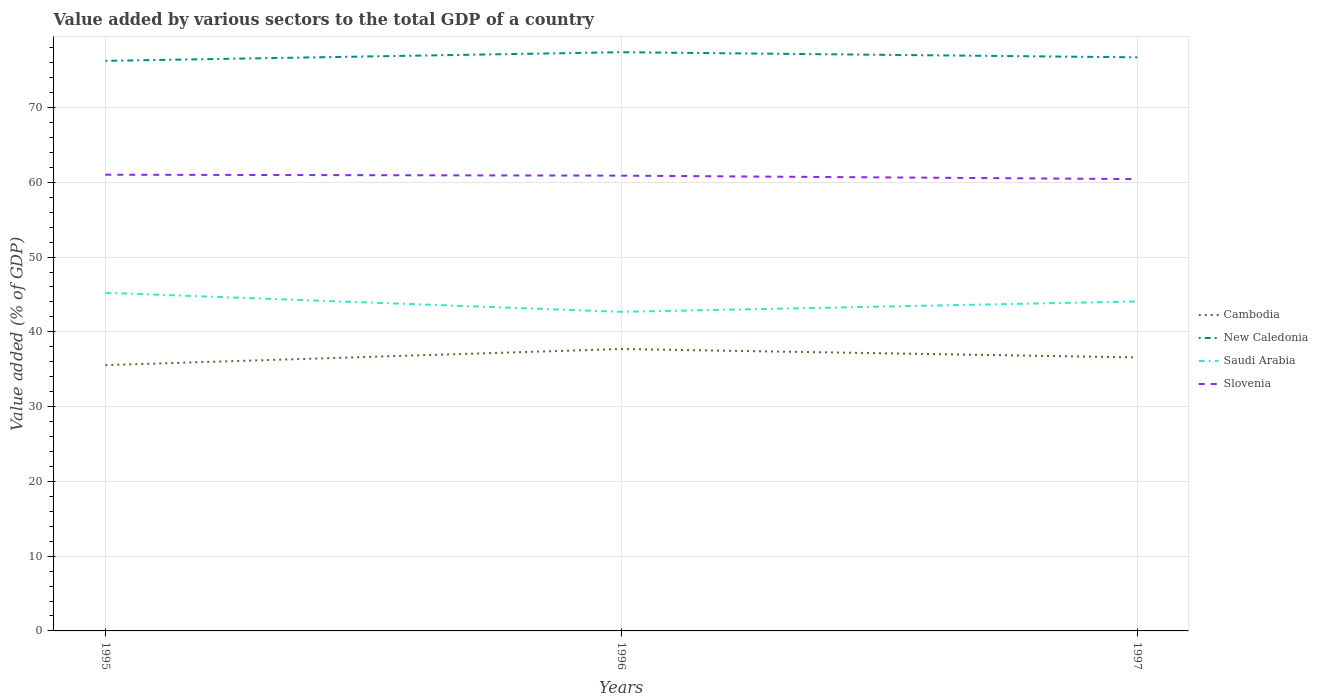How many different coloured lines are there?
Make the answer very short. 4. Does the line corresponding to Saudi Arabia intersect with the line corresponding to Cambodia?
Your answer should be very brief. No. Across all years, what is the maximum value added by various sectors to the total GDP in Slovenia?
Provide a succinct answer. 60.43. In which year was the value added by various sectors to the total GDP in Cambodia maximum?
Keep it short and to the point. 1995. What is the total value added by various sectors to the total GDP in Saudi Arabia in the graph?
Keep it short and to the point. 2.55. What is the difference between the highest and the second highest value added by various sectors to the total GDP in New Caledonia?
Your answer should be very brief. 1.15. Is the value added by various sectors to the total GDP in Saudi Arabia strictly greater than the value added by various sectors to the total GDP in Cambodia over the years?
Offer a very short reply. No. How many years are there in the graph?
Provide a succinct answer. 3. Are the values on the major ticks of Y-axis written in scientific E-notation?
Provide a short and direct response. No. Does the graph contain any zero values?
Ensure brevity in your answer.  No. How many legend labels are there?
Ensure brevity in your answer.  4. How are the legend labels stacked?
Make the answer very short. Vertical. What is the title of the graph?
Keep it short and to the point. Value added by various sectors to the total GDP of a country. What is the label or title of the X-axis?
Your response must be concise. Years. What is the label or title of the Y-axis?
Keep it short and to the point. Value added (% of GDP). What is the Value added (% of GDP) of Cambodia in 1995?
Offer a very short reply. 35.55. What is the Value added (% of GDP) in New Caledonia in 1995?
Your answer should be very brief. 76.24. What is the Value added (% of GDP) in Saudi Arabia in 1995?
Make the answer very short. 45.23. What is the Value added (% of GDP) in Slovenia in 1995?
Your answer should be compact. 61.01. What is the Value added (% of GDP) of Cambodia in 1996?
Give a very brief answer. 37.7. What is the Value added (% of GDP) in New Caledonia in 1996?
Offer a terse response. 77.4. What is the Value added (% of GDP) of Saudi Arabia in 1996?
Keep it short and to the point. 42.67. What is the Value added (% of GDP) in Slovenia in 1996?
Your answer should be compact. 60.89. What is the Value added (% of GDP) of Cambodia in 1997?
Provide a succinct answer. 36.58. What is the Value added (% of GDP) in New Caledonia in 1997?
Your answer should be very brief. 76.71. What is the Value added (% of GDP) of Saudi Arabia in 1997?
Provide a succinct answer. 44.06. What is the Value added (% of GDP) in Slovenia in 1997?
Keep it short and to the point. 60.43. Across all years, what is the maximum Value added (% of GDP) in Cambodia?
Provide a short and direct response. 37.7. Across all years, what is the maximum Value added (% of GDP) in New Caledonia?
Provide a succinct answer. 77.4. Across all years, what is the maximum Value added (% of GDP) of Saudi Arabia?
Ensure brevity in your answer.  45.23. Across all years, what is the maximum Value added (% of GDP) of Slovenia?
Ensure brevity in your answer.  61.01. Across all years, what is the minimum Value added (% of GDP) of Cambodia?
Give a very brief answer. 35.55. Across all years, what is the minimum Value added (% of GDP) in New Caledonia?
Provide a succinct answer. 76.24. Across all years, what is the minimum Value added (% of GDP) of Saudi Arabia?
Your answer should be very brief. 42.67. Across all years, what is the minimum Value added (% of GDP) in Slovenia?
Offer a terse response. 60.43. What is the total Value added (% of GDP) of Cambodia in the graph?
Offer a very short reply. 109.83. What is the total Value added (% of GDP) of New Caledonia in the graph?
Your answer should be compact. 230.36. What is the total Value added (% of GDP) of Saudi Arabia in the graph?
Offer a very short reply. 131.96. What is the total Value added (% of GDP) of Slovenia in the graph?
Your answer should be very brief. 182.33. What is the difference between the Value added (% of GDP) of Cambodia in 1995 and that in 1996?
Make the answer very short. -2.15. What is the difference between the Value added (% of GDP) in New Caledonia in 1995 and that in 1996?
Your answer should be compact. -1.15. What is the difference between the Value added (% of GDP) of Saudi Arabia in 1995 and that in 1996?
Offer a terse response. 2.55. What is the difference between the Value added (% of GDP) in Slovenia in 1995 and that in 1996?
Offer a terse response. 0.12. What is the difference between the Value added (% of GDP) of Cambodia in 1995 and that in 1997?
Offer a terse response. -1.03. What is the difference between the Value added (% of GDP) in New Caledonia in 1995 and that in 1997?
Provide a succinct answer. -0.47. What is the difference between the Value added (% of GDP) in Saudi Arabia in 1995 and that in 1997?
Ensure brevity in your answer.  1.16. What is the difference between the Value added (% of GDP) of Slovenia in 1995 and that in 1997?
Your answer should be compact. 0.59. What is the difference between the Value added (% of GDP) in Cambodia in 1996 and that in 1997?
Ensure brevity in your answer.  1.12. What is the difference between the Value added (% of GDP) of New Caledonia in 1996 and that in 1997?
Offer a very short reply. 0.68. What is the difference between the Value added (% of GDP) of Saudi Arabia in 1996 and that in 1997?
Offer a very short reply. -1.39. What is the difference between the Value added (% of GDP) of Slovenia in 1996 and that in 1997?
Offer a terse response. 0.46. What is the difference between the Value added (% of GDP) of Cambodia in 1995 and the Value added (% of GDP) of New Caledonia in 1996?
Provide a short and direct response. -41.85. What is the difference between the Value added (% of GDP) in Cambodia in 1995 and the Value added (% of GDP) in Saudi Arabia in 1996?
Keep it short and to the point. -7.12. What is the difference between the Value added (% of GDP) in Cambodia in 1995 and the Value added (% of GDP) in Slovenia in 1996?
Give a very brief answer. -25.34. What is the difference between the Value added (% of GDP) of New Caledonia in 1995 and the Value added (% of GDP) of Saudi Arabia in 1996?
Offer a very short reply. 33.57. What is the difference between the Value added (% of GDP) of New Caledonia in 1995 and the Value added (% of GDP) of Slovenia in 1996?
Give a very brief answer. 15.35. What is the difference between the Value added (% of GDP) of Saudi Arabia in 1995 and the Value added (% of GDP) of Slovenia in 1996?
Your response must be concise. -15.66. What is the difference between the Value added (% of GDP) in Cambodia in 1995 and the Value added (% of GDP) in New Caledonia in 1997?
Make the answer very short. -41.16. What is the difference between the Value added (% of GDP) of Cambodia in 1995 and the Value added (% of GDP) of Saudi Arabia in 1997?
Provide a succinct answer. -8.51. What is the difference between the Value added (% of GDP) of Cambodia in 1995 and the Value added (% of GDP) of Slovenia in 1997?
Give a very brief answer. -24.88. What is the difference between the Value added (% of GDP) in New Caledonia in 1995 and the Value added (% of GDP) in Saudi Arabia in 1997?
Your response must be concise. 32.18. What is the difference between the Value added (% of GDP) of New Caledonia in 1995 and the Value added (% of GDP) of Slovenia in 1997?
Give a very brief answer. 15.81. What is the difference between the Value added (% of GDP) of Saudi Arabia in 1995 and the Value added (% of GDP) of Slovenia in 1997?
Offer a terse response. -15.2. What is the difference between the Value added (% of GDP) in Cambodia in 1996 and the Value added (% of GDP) in New Caledonia in 1997?
Ensure brevity in your answer.  -39.01. What is the difference between the Value added (% of GDP) of Cambodia in 1996 and the Value added (% of GDP) of Saudi Arabia in 1997?
Make the answer very short. -6.36. What is the difference between the Value added (% of GDP) of Cambodia in 1996 and the Value added (% of GDP) of Slovenia in 1997?
Offer a very short reply. -22.73. What is the difference between the Value added (% of GDP) of New Caledonia in 1996 and the Value added (% of GDP) of Saudi Arabia in 1997?
Offer a very short reply. 33.33. What is the difference between the Value added (% of GDP) of New Caledonia in 1996 and the Value added (% of GDP) of Slovenia in 1997?
Your answer should be compact. 16.97. What is the difference between the Value added (% of GDP) in Saudi Arabia in 1996 and the Value added (% of GDP) in Slovenia in 1997?
Offer a terse response. -17.76. What is the average Value added (% of GDP) of Cambodia per year?
Provide a succinct answer. 36.61. What is the average Value added (% of GDP) of New Caledonia per year?
Give a very brief answer. 76.78. What is the average Value added (% of GDP) of Saudi Arabia per year?
Provide a short and direct response. 43.99. What is the average Value added (% of GDP) of Slovenia per year?
Keep it short and to the point. 60.78. In the year 1995, what is the difference between the Value added (% of GDP) in Cambodia and Value added (% of GDP) in New Caledonia?
Provide a short and direct response. -40.69. In the year 1995, what is the difference between the Value added (% of GDP) of Cambodia and Value added (% of GDP) of Saudi Arabia?
Make the answer very short. -9.68. In the year 1995, what is the difference between the Value added (% of GDP) in Cambodia and Value added (% of GDP) in Slovenia?
Offer a terse response. -25.46. In the year 1995, what is the difference between the Value added (% of GDP) in New Caledonia and Value added (% of GDP) in Saudi Arabia?
Ensure brevity in your answer.  31.02. In the year 1995, what is the difference between the Value added (% of GDP) in New Caledonia and Value added (% of GDP) in Slovenia?
Give a very brief answer. 15.23. In the year 1995, what is the difference between the Value added (% of GDP) in Saudi Arabia and Value added (% of GDP) in Slovenia?
Provide a succinct answer. -15.79. In the year 1996, what is the difference between the Value added (% of GDP) of Cambodia and Value added (% of GDP) of New Caledonia?
Offer a terse response. -39.69. In the year 1996, what is the difference between the Value added (% of GDP) in Cambodia and Value added (% of GDP) in Saudi Arabia?
Provide a short and direct response. -4.97. In the year 1996, what is the difference between the Value added (% of GDP) of Cambodia and Value added (% of GDP) of Slovenia?
Give a very brief answer. -23.19. In the year 1996, what is the difference between the Value added (% of GDP) in New Caledonia and Value added (% of GDP) in Saudi Arabia?
Give a very brief answer. 34.72. In the year 1996, what is the difference between the Value added (% of GDP) of New Caledonia and Value added (% of GDP) of Slovenia?
Provide a short and direct response. 16.51. In the year 1996, what is the difference between the Value added (% of GDP) of Saudi Arabia and Value added (% of GDP) of Slovenia?
Ensure brevity in your answer.  -18.22. In the year 1997, what is the difference between the Value added (% of GDP) of Cambodia and Value added (% of GDP) of New Caledonia?
Offer a terse response. -40.13. In the year 1997, what is the difference between the Value added (% of GDP) in Cambodia and Value added (% of GDP) in Saudi Arabia?
Give a very brief answer. -7.49. In the year 1997, what is the difference between the Value added (% of GDP) in Cambodia and Value added (% of GDP) in Slovenia?
Provide a succinct answer. -23.85. In the year 1997, what is the difference between the Value added (% of GDP) of New Caledonia and Value added (% of GDP) of Saudi Arabia?
Make the answer very short. 32.65. In the year 1997, what is the difference between the Value added (% of GDP) of New Caledonia and Value added (% of GDP) of Slovenia?
Provide a succinct answer. 16.28. In the year 1997, what is the difference between the Value added (% of GDP) of Saudi Arabia and Value added (% of GDP) of Slovenia?
Give a very brief answer. -16.36. What is the ratio of the Value added (% of GDP) of Cambodia in 1995 to that in 1996?
Your response must be concise. 0.94. What is the ratio of the Value added (% of GDP) of New Caledonia in 1995 to that in 1996?
Give a very brief answer. 0.99. What is the ratio of the Value added (% of GDP) in Saudi Arabia in 1995 to that in 1996?
Your answer should be compact. 1.06. What is the ratio of the Value added (% of GDP) of Slovenia in 1995 to that in 1996?
Your response must be concise. 1. What is the ratio of the Value added (% of GDP) in Cambodia in 1995 to that in 1997?
Provide a succinct answer. 0.97. What is the ratio of the Value added (% of GDP) of Saudi Arabia in 1995 to that in 1997?
Keep it short and to the point. 1.03. What is the ratio of the Value added (% of GDP) in Slovenia in 1995 to that in 1997?
Provide a short and direct response. 1.01. What is the ratio of the Value added (% of GDP) in Cambodia in 1996 to that in 1997?
Provide a succinct answer. 1.03. What is the ratio of the Value added (% of GDP) in New Caledonia in 1996 to that in 1997?
Offer a very short reply. 1.01. What is the ratio of the Value added (% of GDP) in Saudi Arabia in 1996 to that in 1997?
Offer a terse response. 0.97. What is the ratio of the Value added (% of GDP) of Slovenia in 1996 to that in 1997?
Offer a very short reply. 1.01. What is the difference between the highest and the second highest Value added (% of GDP) of Cambodia?
Ensure brevity in your answer.  1.12. What is the difference between the highest and the second highest Value added (% of GDP) in New Caledonia?
Ensure brevity in your answer.  0.68. What is the difference between the highest and the second highest Value added (% of GDP) of Saudi Arabia?
Provide a short and direct response. 1.16. What is the difference between the highest and the second highest Value added (% of GDP) of Slovenia?
Provide a short and direct response. 0.12. What is the difference between the highest and the lowest Value added (% of GDP) in Cambodia?
Ensure brevity in your answer.  2.15. What is the difference between the highest and the lowest Value added (% of GDP) in New Caledonia?
Give a very brief answer. 1.15. What is the difference between the highest and the lowest Value added (% of GDP) in Saudi Arabia?
Offer a very short reply. 2.55. What is the difference between the highest and the lowest Value added (% of GDP) of Slovenia?
Ensure brevity in your answer.  0.59. 